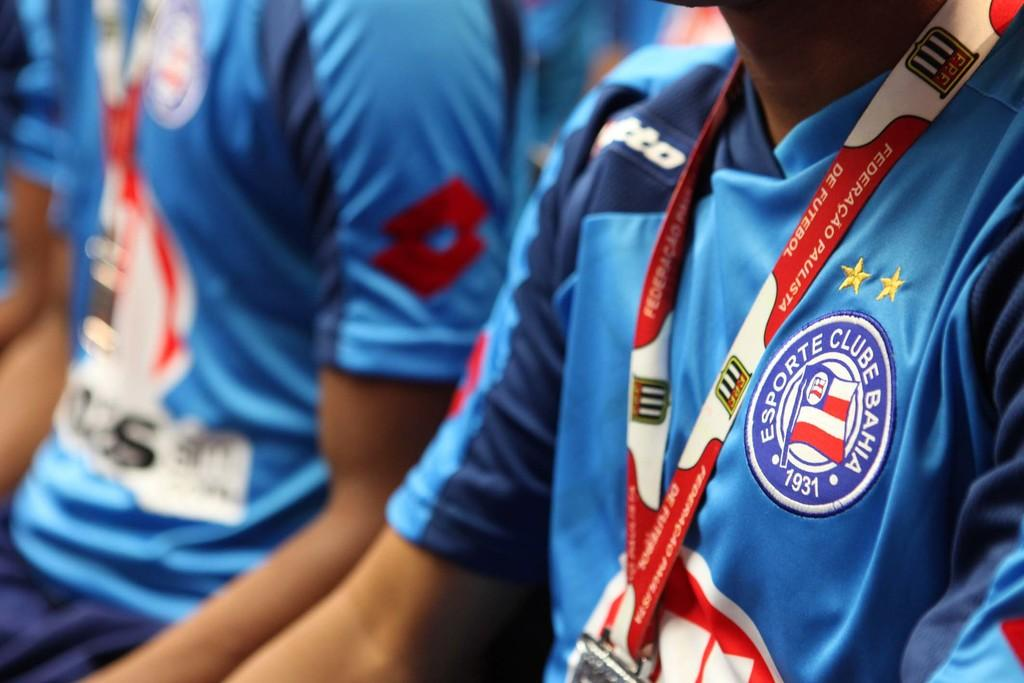Provide a one-sentence caption for the provided image. A pair of athletes wearing blue uniforms representing Esporte Club Bahia. 